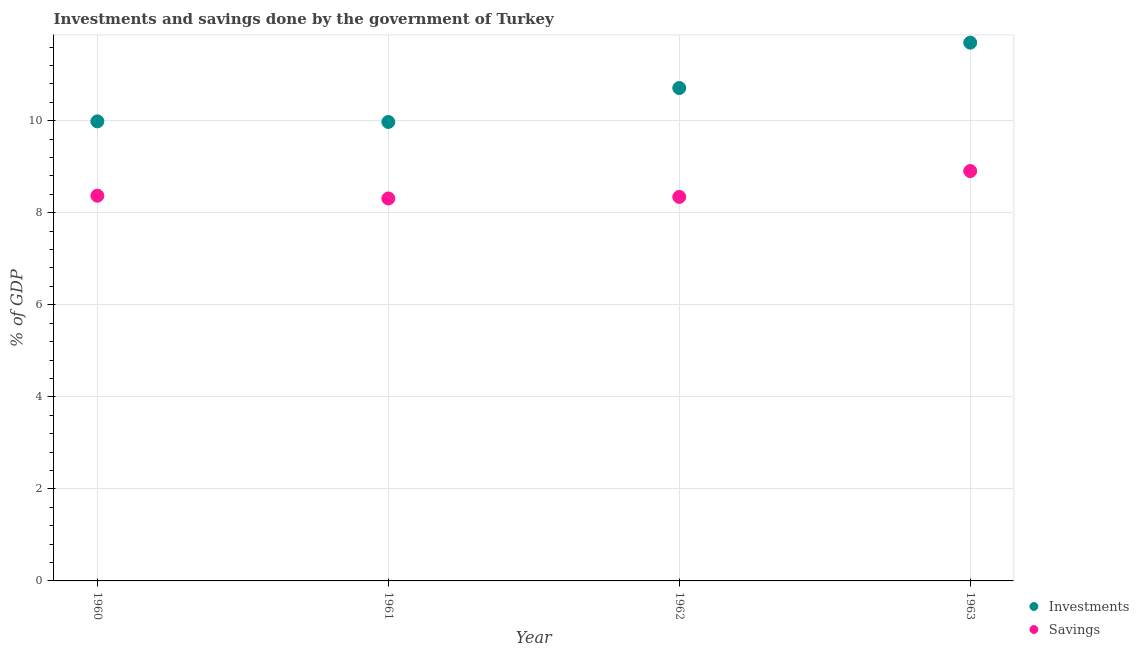How many different coloured dotlines are there?
Ensure brevity in your answer.  2. Is the number of dotlines equal to the number of legend labels?
Your response must be concise. Yes. What is the investments of government in 1962?
Your answer should be very brief. 10.71. Across all years, what is the maximum savings of government?
Your answer should be very brief. 8.91. Across all years, what is the minimum savings of government?
Provide a succinct answer. 8.31. In which year was the investments of government maximum?
Keep it short and to the point. 1963. What is the total investments of government in the graph?
Keep it short and to the point. 42.36. What is the difference between the savings of government in 1960 and that in 1963?
Your response must be concise. -0.54. What is the difference between the investments of government in 1960 and the savings of government in 1962?
Your answer should be compact. 1.64. What is the average savings of government per year?
Give a very brief answer. 8.48. In the year 1963, what is the difference between the investments of government and savings of government?
Your answer should be very brief. 2.79. What is the ratio of the savings of government in 1962 to that in 1963?
Offer a very short reply. 0.94. Is the savings of government in 1962 less than that in 1963?
Offer a terse response. Yes. What is the difference between the highest and the second highest savings of government?
Your answer should be compact. 0.54. What is the difference between the highest and the lowest investments of government?
Your answer should be very brief. 1.72. In how many years, is the investments of government greater than the average investments of government taken over all years?
Your answer should be very brief. 2. Is the sum of the savings of government in 1960 and 1963 greater than the maximum investments of government across all years?
Your answer should be very brief. Yes. Does the investments of government monotonically increase over the years?
Provide a short and direct response. No. How many dotlines are there?
Ensure brevity in your answer.  2. How many years are there in the graph?
Provide a short and direct response. 4. What is the difference between two consecutive major ticks on the Y-axis?
Provide a succinct answer. 2. Are the values on the major ticks of Y-axis written in scientific E-notation?
Give a very brief answer. No. Does the graph contain any zero values?
Offer a very short reply. No. How are the legend labels stacked?
Your response must be concise. Vertical. What is the title of the graph?
Provide a succinct answer. Investments and savings done by the government of Turkey. What is the label or title of the Y-axis?
Your answer should be very brief. % of GDP. What is the % of GDP of Investments in 1960?
Your response must be concise. 9.99. What is the % of GDP of Savings in 1960?
Your response must be concise. 8.37. What is the % of GDP of Investments in 1961?
Keep it short and to the point. 9.97. What is the % of GDP in Savings in 1961?
Give a very brief answer. 8.31. What is the % of GDP of Investments in 1962?
Your answer should be compact. 10.71. What is the % of GDP of Savings in 1962?
Ensure brevity in your answer.  8.34. What is the % of GDP of Investments in 1963?
Provide a short and direct response. 11.7. What is the % of GDP of Savings in 1963?
Provide a succinct answer. 8.91. Across all years, what is the maximum % of GDP of Investments?
Your answer should be very brief. 11.7. Across all years, what is the maximum % of GDP of Savings?
Your answer should be compact. 8.91. Across all years, what is the minimum % of GDP of Investments?
Make the answer very short. 9.97. Across all years, what is the minimum % of GDP in Savings?
Provide a succinct answer. 8.31. What is the total % of GDP of Investments in the graph?
Your answer should be very brief. 42.36. What is the total % of GDP in Savings in the graph?
Your response must be concise. 33.93. What is the difference between the % of GDP in Investments in 1960 and that in 1961?
Offer a very short reply. 0.01. What is the difference between the % of GDP in Savings in 1960 and that in 1961?
Offer a terse response. 0.06. What is the difference between the % of GDP of Investments in 1960 and that in 1962?
Keep it short and to the point. -0.72. What is the difference between the % of GDP in Savings in 1960 and that in 1962?
Your answer should be compact. 0.03. What is the difference between the % of GDP in Investments in 1960 and that in 1963?
Provide a short and direct response. -1.71. What is the difference between the % of GDP in Savings in 1960 and that in 1963?
Give a very brief answer. -0.54. What is the difference between the % of GDP in Investments in 1961 and that in 1962?
Your answer should be very brief. -0.74. What is the difference between the % of GDP in Savings in 1961 and that in 1962?
Your answer should be very brief. -0.03. What is the difference between the % of GDP in Investments in 1961 and that in 1963?
Ensure brevity in your answer.  -1.72. What is the difference between the % of GDP in Savings in 1961 and that in 1963?
Ensure brevity in your answer.  -0.6. What is the difference between the % of GDP of Investments in 1962 and that in 1963?
Your answer should be very brief. -0.99. What is the difference between the % of GDP in Savings in 1962 and that in 1963?
Your answer should be very brief. -0.56. What is the difference between the % of GDP of Investments in 1960 and the % of GDP of Savings in 1961?
Keep it short and to the point. 1.68. What is the difference between the % of GDP of Investments in 1960 and the % of GDP of Savings in 1962?
Your answer should be compact. 1.64. What is the difference between the % of GDP in Investments in 1960 and the % of GDP in Savings in 1963?
Provide a short and direct response. 1.08. What is the difference between the % of GDP in Investments in 1961 and the % of GDP in Savings in 1962?
Provide a short and direct response. 1.63. What is the difference between the % of GDP in Investments in 1961 and the % of GDP in Savings in 1963?
Provide a short and direct response. 1.07. What is the difference between the % of GDP of Investments in 1962 and the % of GDP of Savings in 1963?
Make the answer very short. 1.8. What is the average % of GDP of Investments per year?
Provide a short and direct response. 10.59. What is the average % of GDP in Savings per year?
Ensure brevity in your answer.  8.48. In the year 1960, what is the difference between the % of GDP of Investments and % of GDP of Savings?
Give a very brief answer. 1.62. In the year 1961, what is the difference between the % of GDP in Investments and % of GDP in Savings?
Make the answer very short. 1.66. In the year 1962, what is the difference between the % of GDP in Investments and % of GDP in Savings?
Provide a succinct answer. 2.37. In the year 1963, what is the difference between the % of GDP in Investments and % of GDP in Savings?
Your response must be concise. 2.79. What is the ratio of the % of GDP of Investments in 1960 to that in 1961?
Your answer should be compact. 1. What is the ratio of the % of GDP of Savings in 1960 to that in 1961?
Your response must be concise. 1.01. What is the ratio of the % of GDP in Investments in 1960 to that in 1962?
Your answer should be very brief. 0.93. What is the ratio of the % of GDP of Investments in 1960 to that in 1963?
Provide a succinct answer. 0.85. What is the ratio of the % of GDP of Savings in 1960 to that in 1963?
Your answer should be very brief. 0.94. What is the ratio of the % of GDP in Investments in 1961 to that in 1962?
Your answer should be compact. 0.93. What is the ratio of the % of GDP of Investments in 1961 to that in 1963?
Give a very brief answer. 0.85. What is the ratio of the % of GDP of Savings in 1961 to that in 1963?
Provide a succinct answer. 0.93. What is the ratio of the % of GDP in Investments in 1962 to that in 1963?
Offer a very short reply. 0.92. What is the ratio of the % of GDP of Savings in 1962 to that in 1963?
Ensure brevity in your answer.  0.94. What is the difference between the highest and the second highest % of GDP of Investments?
Give a very brief answer. 0.99. What is the difference between the highest and the second highest % of GDP in Savings?
Keep it short and to the point. 0.54. What is the difference between the highest and the lowest % of GDP of Investments?
Provide a short and direct response. 1.72. What is the difference between the highest and the lowest % of GDP of Savings?
Ensure brevity in your answer.  0.6. 